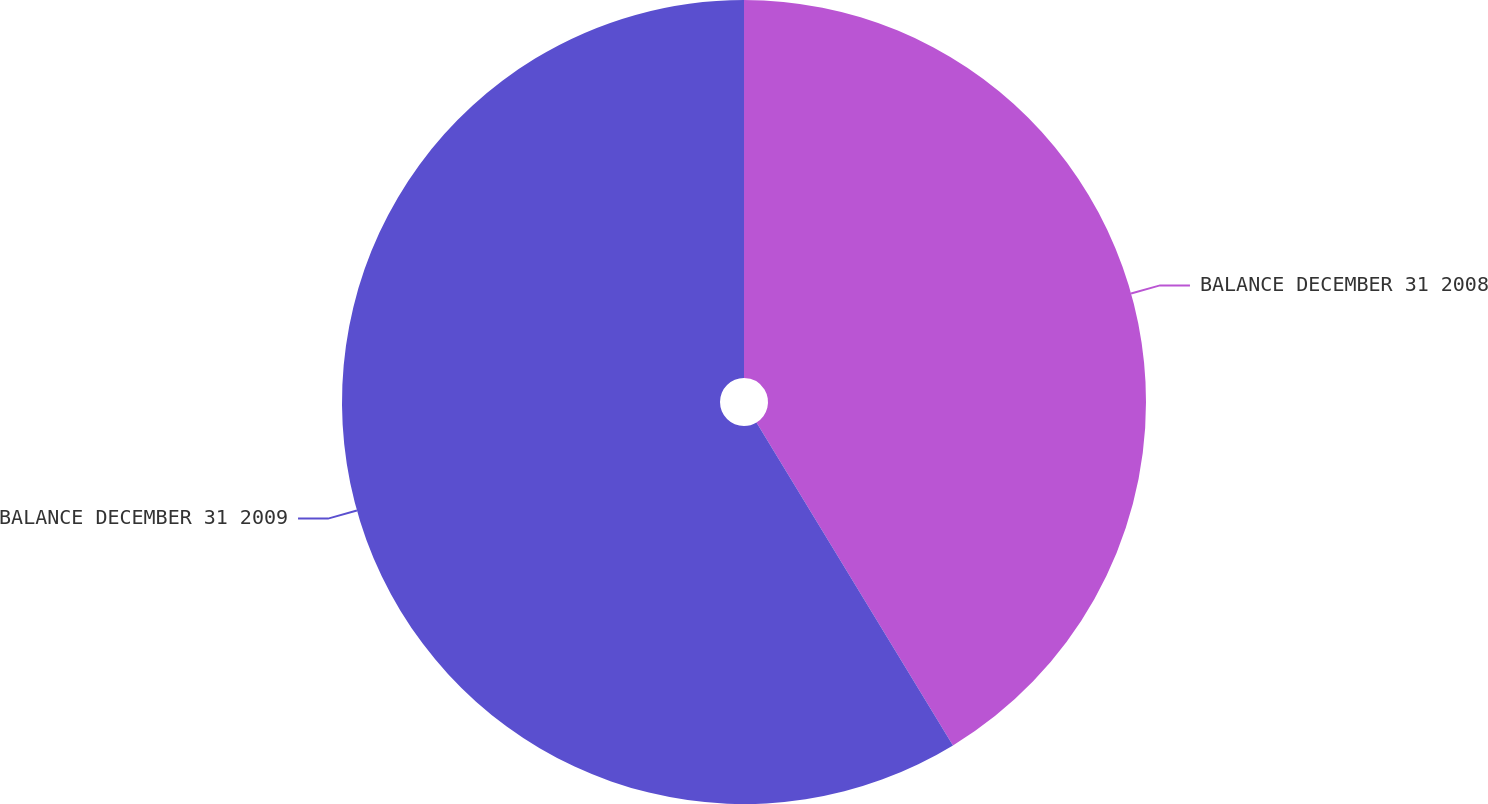Convert chart to OTSL. <chart><loc_0><loc_0><loc_500><loc_500><pie_chart><fcel>BALANCE DECEMBER 31 2008<fcel>BALANCE DECEMBER 31 2009<nl><fcel>41.3%<fcel>58.7%<nl></chart> 